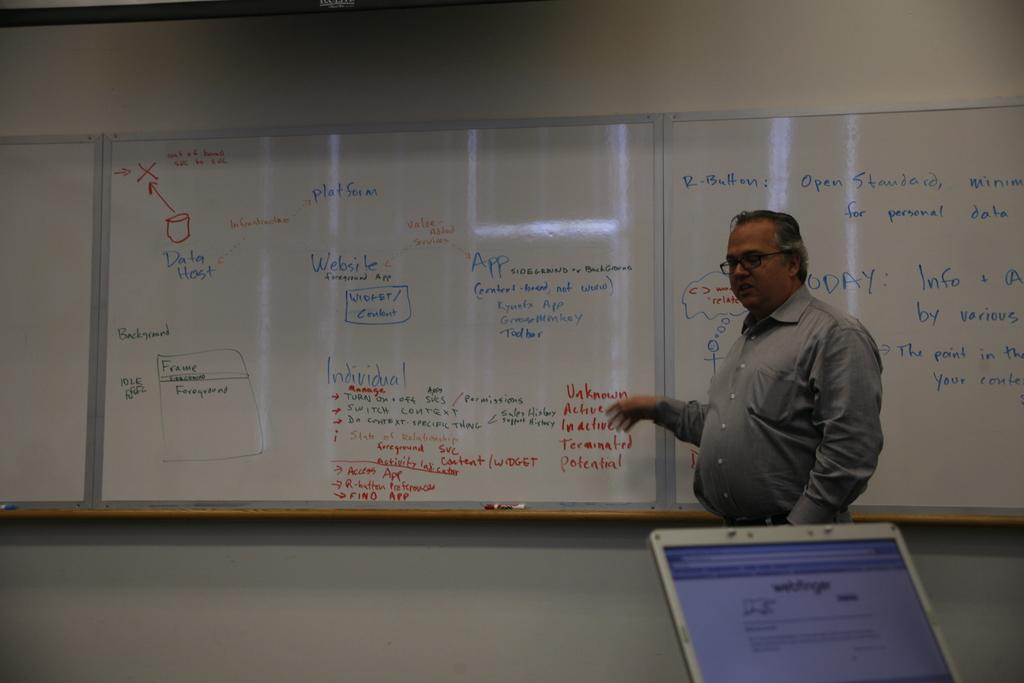<image>
Share a concise interpretation of the image provided. A man giving a speech in front of a white board pointing to the word unknown. 